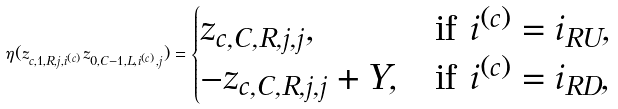<formula> <loc_0><loc_0><loc_500><loc_500>\eta ( z _ { c , 1 , R , j , i ^ { ( c ) } } z _ { 0 , C - 1 , L , i ^ { ( c ) } , j } ) = \begin{cases} z _ { c , C , R , j , j } , & \text {if $i^{(c)} = i_{RU}$} , \\ - z _ { c , C , R , j , j } + Y , & \text {if $i^{(c)} = i_{RD}$} , \end{cases}</formula> 